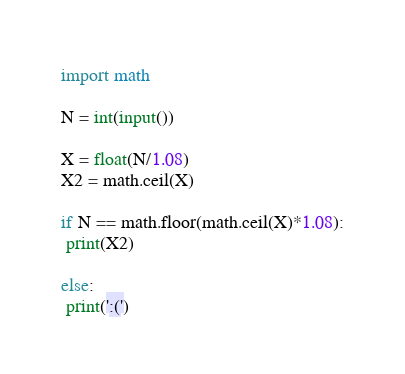<code> <loc_0><loc_0><loc_500><loc_500><_Python_>import math

N = int(input())

X = float(N/1.08)
X2 = math.ceil(X)

if N == math.floor(math.ceil(X)*1.08):
 print(X2)

else:
 print(':(')

</code> 